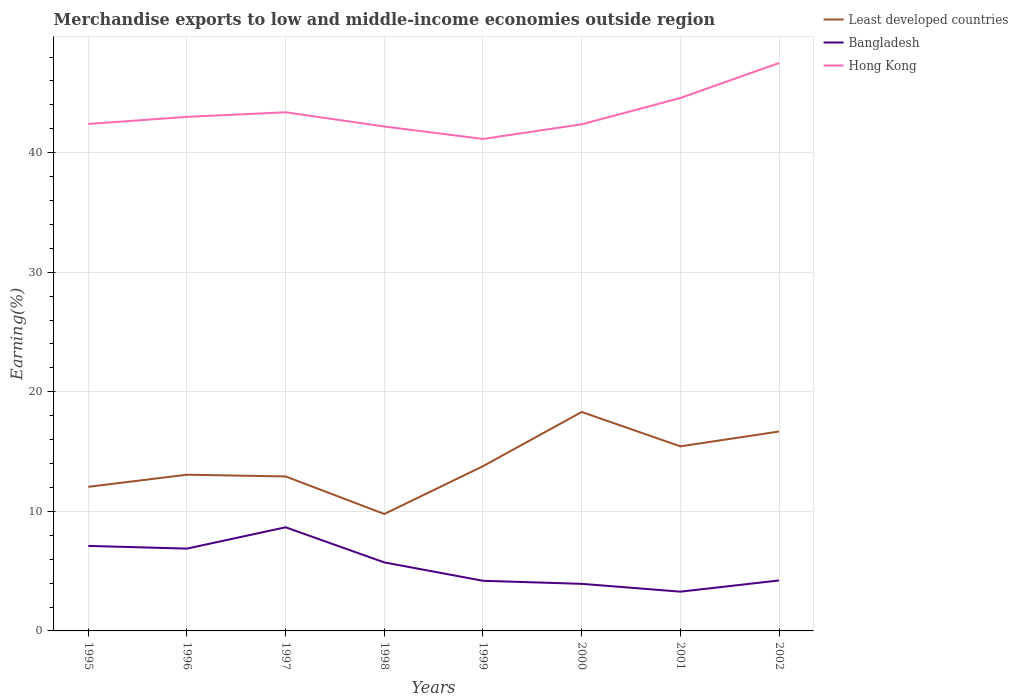Does the line corresponding to Least developed countries intersect with the line corresponding to Hong Kong?
Your response must be concise. No. Is the number of lines equal to the number of legend labels?
Provide a short and direct response. Yes. Across all years, what is the maximum percentage of amount earned from merchandise exports in Hong Kong?
Offer a very short reply. 41.15. What is the total percentage of amount earned from merchandise exports in Least developed countries in the graph?
Provide a succinct answer. -8.53. What is the difference between the highest and the second highest percentage of amount earned from merchandise exports in Least developed countries?
Your answer should be very brief. 8.53. What is the difference between the highest and the lowest percentage of amount earned from merchandise exports in Hong Kong?
Your response must be concise. 3. How many years are there in the graph?
Offer a very short reply. 8. Are the values on the major ticks of Y-axis written in scientific E-notation?
Ensure brevity in your answer.  No. Does the graph contain grids?
Provide a succinct answer. Yes. Where does the legend appear in the graph?
Keep it short and to the point. Top right. How are the legend labels stacked?
Provide a succinct answer. Vertical. What is the title of the graph?
Provide a succinct answer. Merchandise exports to low and middle-income economies outside region. Does "Bolivia" appear as one of the legend labels in the graph?
Provide a succinct answer. No. What is the label or title of the Y-axis?
Your answer should be compact. Earning(%). What is the Earning(%) in Least developed countries in 1995?
Offer a terse response. 12.05. What is the Earning(%) of Bangladesh in 1995?
Offer a terse response. 7.11. What is the Earning(%) in Hong Kong in 1995?
Give a very brief answer. 42.4. What is the Earning(%) in Least developed countries in 1996?
Provide a succinct answer. 13.07. What is the Earning(%) in Bangladesh in 1996?
Provide a short and direct response. 6.88. What is the Earning(%) of Hong Kong in 1996?
Your response must be concise. 43. What is the Earning(%) in Least developed countries in 1997?
Make the answer very short. 12.92. What is the Earning(%) in Bangladesh in 1997?
Offer a terse response. 8.67. What is the Earning(%) of Hong Kong in 1997?
Your answer should be very brief. 43.38. What is the Earning(%) of Least developed countries in 1998?
Offer a terse response. 9.78. What is the Earning(%) of Bangladesh in 1998?
Ensure brevity in your answer.  5.73. What is the Earning(%) in Hong Kong in 1998?
Offer a terse response. 42.19. What is the Earning(%) in Least developed countries in 1999?
Your answer should be compact. 13.78. What is the Earning(%) in Bangladesh in 1999?
Offer a very short reply. 4.19. What is the Earning(%) of Hong Kong in 1999?
Your response must be concise. 41.15. What is the Earning(%) of Least developed countries in 2000?
Give a very brief answer. 18.31. What is the Earning(%) in Bangladesh in 2000?
Ensure brevity in your answer.  3.94. What is the Earning(%) of Hong Kong in 2000?
Offer a very short reply. 42.37. What is the Earning(%) in Least developed countries in 2001?
Give a very brief answer. 15.44. What is the Earning(%) in Bangladesh in 2001?
Your answer should be very brief. 3.28. What is the Earning(%) of Hong Kong in 2001?
Keep it short and to the point. 44.58. What is the Earning(%) in Least developed countries in 2002?
Provide a succinct answer. 16.68. What is the Earning(%) of Bangladesh in 2002?
Offer a terse response. 4.22. What is the Earning(%) in Hong Kong in 2002?
Ensure brevity in your answer.  47.5. Across all years, what is the maximum Earning(%) of Least developed countries?
Your response must be concise. 18.31. Across all years, what is the maximum Earning(%) of Bangladesh?
Give a very brief answer. 8.67. Across all years, what is the maximum Earning(%) in Hong Kong?
Give a very brief answer. 47.5. Across all years, what is the minimum Earning(%) of Least developed countries?
Offer a very short reply. 9.78. Across all years, what is the minimum Earning(%) of Bangladesh?
Offer a very short reply. 3.28. Across all years, what is the minimum Earning(%) in Hong Kong?
Ensure brevity in your answer.  41.15. What is the total Earning(%) in Least developed countries in the graph?
Give a very brief answer. 112.03. What is the total Earning(%) in Bangladesh in the graph?
Make the answer very short. 44.03. What is the total Earning(%) in Hong Kong in the graph?
Offer a terse response. 346.57. What is the difference between the Earning(%) in Least developed countries in 1995 and that in 1996?
Your answer should be compact. -1.01. What is the difference between the Earning(%) of Bangladesh in 1995 and that in 1996?
Your answer should be very brief. 0.23. What is the difference between the Earning(%) of Hong Kong in 1995 and that in 1996?
Provide a short and direct response. -0.6. What is the difference between the Earning(%) of Least developed countries in 1995 and that in 1997?
Your answer should be very brief. -0.87. What is the difference between the Earning(%) of Bangladesh in 1995 and that in 1997?
Your response must be concise. -1.56. What is the difference between the Earning(%) in Hong Kong in 1995 and that in 1997?
Your response must be concise. -0.98. What is the difference between the Earning(%) of Least developed countries in 1995 and that in 1998?
Give a very brief answer. 2.27. What is the difference between the Earning(%) in Bangladesh in 1995 and that in 1998?
Your response must be concise. 1.38. What is the difference between the Earning(%) of Hong Kong in 1995 and that in 1998?
Offer a terse response. 0.21. What is the difference between the Earning(%) in Least developed countries in 1995 and that in 1999?
Keep it short and to the point. -1.73. What is the difference between the Earning(%) in Bangladesh in 1995 and that in 1999?
Make the answer very short. 2.92. What is the difference between the Earning(%) of Hong Kong in 1995 and that in 1999?
Offer a very short reply. 1.25. What is the difference between the Earning(%) of Least developed countries in 1995 and that in 2000?
Offer a very short reply. -6.26. What is the difference between the Earning(%) in Bangladesh in 1995 and that in 2000?
Offer a terse response. 3.17. What is the difference between the Earning(%) of Hong Kong in 1995 and that in 2000?
Your answer should be compact. 0.03. What is the difference between the Earning(%) of Least developed countries in 1995 and that in 2001?
Make the answer very short. -3.39. What is the difference between the Earning(%) in Bangladesh in 1995 and that in 2001?
Give a very brief answer. 3.83. What is the difference between the Earning(%) of Hong Kong in 1995 and that in 2001?
Provide a short and direct response. -2.17. What is the difference between the Earning(%) in Least developed countries in 1995 and that in 2002?
Offer a very short reply. -4.63. What is the difference between the Earning(%) in Bangladesh in 1995 and that in 2002?
Ensure brevity in your answer.  2.89. What is the difference between the Earning(%) in Hong Kong in 1995 and that in 2002?
Provide a short and direct response. -5.1. What is the difference between the Earning(%) of Least developed countries in 1996 and that in 1997?
Offer a very short reply. 0.14. What is the difference between the Earning(%) in Bangladesh in 1996 and that in 1997?
Your response must be concise. -1.78. What is the difference between the Earning(%) of Hong Kong in 1996 and that in 1997?
Keep it short and to the point. -0.38. What is the difference between the Earning(%) in Least developed countries in 1996 and that in 1998?
Offer a terse response. 3.29. What is the difference between the Earning(%) in Bangladesh in 1996 and that in 1998?
Offer a very short reply. 1.15. What is the difference between the Earning(%) of Hong Kong in 1996 and that in 1998?
Your answer should be compact. 0.81. What is the difference between the Earning(%) in Least developed countries in 1996 and that in 1999?
Offer a terse response. -0.71. What is the difference between the Earning(%) in Bangladesh in 1996 and that in 1999?
Your answer should be compact. 2.69. What is the difference between the Earning(%) of Hong Kong in 1996 and that in 1999?
Provide a short and direct response. 1.85. What is the difference between the Earning(%) of Least developed countries in 1996 and that in 2000?
Offer a very short reply. -5.25. What is the difference between the Earning(%) in Bangladesh in 1996 and that in 2000?
Keep it short and to the point. 2.95. What is the difference between the Earning(%) in Hong Kong in 1996 and that in 2000?
Your response must be concise. 0.62. What is the difference between the Earning(%) of Least developed countries in 1996 and that in 2001?
Your answer should be compact. -2.37. What is the difference between the Earning(%) of Bangladesh in 1996 and that in 2001?
Your response must be concise. 3.6. What is the difference between the Earning(%) in Hong Kong in 1996 and that in 2001?
Your response must be concise. -1.58. What is the difference between the Earning(%) in Least developed countries in 1996 and that in 2002?
Your answer should be compact. -3.61. What is the difference between the Earning(%) in Bangladesh in 1996 and that in 2002?
Offer a terse response. 2.66. What is the difference between the Earning(%) of Hong Kong in 1996 and that in 2002?
Provide a short and direct response. -4.5. What is the difference between the Earning(%) of Least developed countries in 1997 and that in 1998?
Your answer should be very brief. 3.14. What is the difference between the Earning(%) of Bangladesh in 1997 and that in 1998?
Your response must be concise. 2.94. What is the difference between the Earning(%) of Hong Kong in 1997 and that in 1998?
Offer a very short reply. 1.19. What is the difference between the Earning(%) in Least developed countries in 1997 and that in 1999?
Your response must be concise. -0.86. What is the difference between the Earning(%) of Bangladesh in 1997 and that in 1999?
Offer a terse response. 4.47. What is the difference between the Earning(%) of Hong Kong in 1997 and that in 1999?
Your answer should be very brief. 2.23. What is the difference between the Earning(%) in Least developed countries in 1997 and that in 2000?
Your answer should be compact. -5.39. What is the difference between the Earning(%) in Bangladesh in 1997 and that in 2000?
Give a very brief answer. 4.73. What is the difference between the Earning(%) of Least developed countries in 1997 and that in 2001?
Provide a short and direct response. -2.52. What is the difference between the Earning(%) of Bangladesh in 1997 and that in 2001?
Your answer should be very brief. 5.38. What is the difference between the Earning(%) of Hong Kong in 1997 and that in 2001?
Offer a terse response. -1.19. What is the difference between the Earning(%) in Least developed countries in 1997 and that in 2002?
Give a very brief answer. -3.76. What is the difference between the Earning(%) in Bangladesh in 1997 and that in 2002?
Provide a short and direct response. 4.45. What is the difference between the Earning(%) in Hong Kong in 1997 and that in 2002?
Your response must be concise. -4.12. What is the difference between the Earning(%) in Least developed countries in 1998 and that in 1999?
Your answer should be very brief. -4. What is the difference between the Earning(%) in Bangladesh in 1998 and that in 1999?
Ensure brevity in your answer.  1.54. What is the difference between the Earning(%) of Hong Kong in 1998 and that in 1999?
Ensure brevity in your answer.  1.04. What is the difference between the Earning(%) of Least developed countries in 1998 and that in 2000?
Your response must be concise. -8.53. What is the difference between the Earning(%) of Bangladesh in 1998 and that in 2000?
Your response must be concise. 1.79. What is the difference between the Earning(%) of Hong Kong in 1998 and that in 2000?
Provide a short and direct response. -0.18. What is the difference between the Earning(%) in Least developed countries in 1998 and that in 2001?
Make the answer very short. -5.66. What is the difference between the Earning(%) in Bangladesh in 1998 and that in 2001?
Provide a succinct answer. 2.45. What is the difference between the Earning(%) of Hong Kong in 1998 and that in 2001?
Provide a short and direct response. -2.39. What is the difference between the Earning(%) of Least developed countries in 1998 and that in 2002?
Offer a terse response. -6.9. What is the difference between the Earning(%) of Bangladesh in 1998 and that in 2002?
Ensure brevity in your answer.  1.51. What is the difference between the Earning(%) of Hong Kong in 1998 and that in 2002?
Your response must be concise. -5.31. What is the difference between the Earning(%) in Least developed countries in 1999 and that in 2000?
Make the answer very short. -4.53. What is the difference between the Earning(%) in Bangladesh in 1999 and that in 2000?
Make the answer very short. 0.26. What is the difference between the Earning(%) in Hong Kong in 1999 and that in 2000?
Make the answer very short. -1.22. What is the difference between the Earning(%) in Least developed countries in 1999 and that in 2001?
Your answer should be compact. -1.66. What is the difference between the Earning(%) in Bangladesh in 1999 and that in 2001?
Your answer should be compact. 0.91. What is the difference between the Earning(%) of Hong Kong in 1999 and that in 2001?
Provide a succinct answer. -3.43. What is the difference between the Earning(%) in Least developed countries in 1999 and that in 2002?
Offer a terse response. -2.9. What is the difference between the Earning(%) of Bangladesh in 1999 and that in 2002?
Give a very brief answer. -0.03. What is the difference between the Earning(%) in Hong Kong in 1999 and that in 2002?
Provide a succinct answer. -6.35. What is the difference between the Earning(%) of Least developed countries in 2000 and that in 2001?
Offer a very short reply. 2.87. What is the difference between the Earning(%) of Bangladesh in 2000 and that in 2001?
Make the answer very short. 0.65. What is the difference between the Earning(%) of Hong Kong in 2000 and that in 2001?
Give a very brief answer. -2.2. What is the difference between the Earning(%) in Least developed countries in 2000 and that in 2002?
Your answer should be compact. 1.63. What is the difference between the Earning(%) in Bangladesh in 2000 and that in 2002?
Offer a very short reply. -0.28. What is the difference between the Earning(%) of Hong Kong in 2000 and that in 2002?
Keep it short and to the point. -5.13. What is the difference between the Earning(%) of Least developed countries in 2001 and that in 2002?
Keep it short and to the point. -1.24. What is the difference between the Earning(%) of Bangladesh in 2001 and that in 2002?
Your response must be concise. -0.94. What is the difference between the Earning(%) of Hong Kong in 2001 and that in 2002?
Offer a terse response. -2.93. What is the difference between the Earning(%) of Least developed countries in 1995 and the Earning(%) of Bangladesh in 1996?
Your answer should be compact. 5.17. What is the difference between the Earning(%) in Least developed countries in 1995 and the Earning(%) in Hong Kong in 1996?
Your answer should be compact. -30.94. What is the difference between the Earning(%) of Bangladesh in 1995 and the Earning(%) of Hong Kong in 1996?
Give a very brief answer. -35.89. What is the difference between the Earning(%) in Least developed countries in 1995 and the Earning(%) in Bangladesh in 1997?
Ensure brevity in your answer.  3.38. What is the difference between the Earning(%) in Least developed countries in 1995 and the Earning(%) in Hong Kong in 1997?
Keep it short and to the point. -31.33. What is the difference between the Earning(%) in Bangladesh in 1995 and the Earning(%) in Hong Kong in 1997?
Offer a terse response. -36.27. What is the difference between the Earning(%) in Least developed countries in 1995 and the Earning(%) in Bangladesh in 1998?
Your answer should be very brief. 6.32. What is the difference between the Earning(%) in Least developed countries in 1995 and the Earning(%) in Hong Kong in 1998?
Give a very brief answer. -30.14. What is the difference between the Earning(%) of Bangladesh in 1995 and the Earning(%) of Hong Kong in 1998?
Provide a short and direct response. -35.08. What is the difference between the Earning(%) in Least developed countries in 1995 and the Earning(%) in Bangladesh in 1999?
Keep it short and to the point. 7.86. What is the difference between the Earning(%) of Least developed countries in 1995 and the Earning(%) of Hong Kong in 1999?
Offer a very short reply. -29.1. What is the difference between the Earning(%) in Bangladesh in 1995 and the Earning(%) in Hong Kong in 1999?
Your answer should be very brief. -34.04. What is the difference between the Earning(%) in Least developed countries in 1995 and the Earning(%) in Bangladesh in 2000?
Provide a succinct answer. 8.11. What is the difference between the Earning(%) in Least developed countries in 1995 and the Earning(%) in Hong Kong in 2000?
Your answer should be very brief. -30.32. What is the difference between the Earning(%) of Bangladesh in 1995 and the Earning(%) of Hong Kong in 2000?
Make the answer very short. -35.26. What is the difference between the Earning(%) in Least developed countries in 1995 and the Earning(%) in Bangladesh in 2001?
Give a very brief answer. 8.77. What is the difference between the Earning(%) of Least developed countries in 1995 and the Earning(%) of Hong Kong in 2001?
Give a very brief answer. -32.52. What is the difference between the Earning(%) of Bangladesh in 1995 and the Earning(%) of Hong Kong in 2001?
Provide a succinct answer. -37.46. What is the difference between the Earning(%) of Least developed countries in 1995 and the Earning(%) of Bangladesh in 2002?
Give a very brief answer. 7.83. What is the difference between the Earning(%) of Least developed countries in 1995 and the Earning(%) of Hong Kong in 2002?
Your answer should be very brief. -35.45. What is the difference between the Earning(%) of Bangladesh in 1995 and the Earning(%) of Hong Kong in 2002?
Offer a terse response. -40.39. What is the difference between the Earning(%) of Least developed countries in 1996 and the Earning(%) of Bangladesh in 1997?
Make the answer very short. 4.4. What is the difference between the Earning(%) of Least developed countries in 1996 and the Earning(%) of Hong Kong in 1997?
Keep it short and to the point. -30.32. What is the difference between the Earning(%) in Bangladesh in 1996 and the Earning(%) in Hong Kong in 1997?
Your response must be concise. -36.5. What is the difference between the Earning(%) in Least developed countries in 1996 and the Earning(%) in Bangladesh in 1998?
Offer a terse response. 7.33. What is the difference between the Earning(%) in Least developed countries in 1996 and the Earning(%) in Hong Kong in 1998?
Provide a short and direct response. -29.12. What is the difference between the Earning(%) of Bangladesh in 1996 and the Earning(%) of Hong Kong in 1998?
Keep it short and to the point. -35.3. What is the difference between the Earning(%) in Least developed countries in 1996 and the Earning(%) in Bangladesh in 1999?
Keep it short and to the point. 8.87. What is the difference between the Earning(%) in Least developed countries in 1996 and the Earning(%) in Hong Kong in 1999?
Provide a succinct answer. -28.08. What is the difference between the Earning(%) of Bangladesh in 1996 and the Earning(%) of Hong Kong in 1999?
Ensure brevity in your answer.  -34.27. What is the difference between the Earning(%) of Least developed countries in 1996 and the Earning(%) of Bangladesh in 2000?
Offer a terse response. 9.13. What is the difference between the Earning(%) of Least developed countries in 1996 and the Earning(%) of Hong Kong in 2000?
Provide a succinct answer. -29.31. What is the difference between the Earning(%) in Bangladesh in 1996 and the Earning(%) in Hong Kong in 2000?
Your answer should be compact. -35.49. What is the difference between the Earning(%) of Least developed countries in 1996 and the Earning(%) of Bangladesh in 2001?
Provide a short and direct response. 9.78. What is the difference between the Earning(%) of Least developed countries in 1996 and the Earning(%) of Hong Kong in 2001?
Provide a short and direct response. -31.51. What is the difference between the Earning(%) in Bangladesh in 1996 and the Earning(%) in Hong Kong in 2001?
Provide a short and direct response. -37.69. What is the difference between the Earning(%) of Least developed countries in 1996 and the Earning(%) of Bangladesh in 2002?
Your answer should be very brief. 8.85. What is the difference between the Earning(%) in Least developed countries in 1996 and the Earning(%) in Hong Kong in 2002?
Keep it short and to the point. -34.44. What is the difference between the Earning(%) of Bangladesh in 1996 and the Earning(%) of Hong Kong in 2002?
Your answer should be very brief. -40.62. What is the difference between the Earning(%) in Least developed countries in 1997 and the Earning(%) in Bangladesh in 1998?
Your response must be concise. 7.19. What is the difference between the Earning(%) in Least developed countries in 1997 and the Earning(%) in Hong Kong in 1998?
Your answer should be very brief. -29.27. What is the difference between the Earning(%) of Bangladesh in 1997 and the Earning(%) of Hong Kong in 1998?
Ensure brevity in your answer.  -33.52. What is the difference between the Earning(%) in Least developed countries in 1997 and the Earning(%) in Bangladesh in 1999?
Give a very brief answer. 8.73. What is the difference between the Earning(%) in Least developed countries in 1997 and the Earning(%) in Hong Kong in 1999?
Provide a succinct answer. -28.23. What is the difference between the Earning(%) of Bangladesh in 1997 and the Earning(%) of Hong Kong in 1999?
Give a very brief answer. -32.48. What is the difference between the Earning(%) of Least developed countries in 1997 and the Earning(%) of Bangladesh in 2000?
Offer a terse response. 8.98. What is the difference between the Earning(%) in Least developed countries in 1997 and the Earning(%) in Hong Kong in 2000?
Ensure brevity in your answer.  -29.45. What is the difference between the Earning(%) in Bangladesh in 1997 and the Earning(%) in Hong Kong in 2000?
Provide a succinct answer. -33.71. What is the difference between the Earning(%) of Least developed countries in 1997 and the Earning(%) of Bangladesh in 2001?
Provide a succinct answer. 9.64. What is the difference between the Earning(%) of Least developed countries in 1997 and the Earning(%) of Hong Kong in 2001?
Provide a short and direct response. -31.65. What is the difference between the Earning(%) in Bangladesh in 1997 and the Earning(%) in Hong Kong in 2001?
Make the answer very short. -35.91. What is the difference between the Earning(%) in Least developed countries in 1997 and the Earning(%) in Bangladesh in 2002?
Your answer should be very brief. 8.7. What is the difference between the Earning(%) in Least developed countries in 1997 and the Earning(%) in Hong Kong in 2002?
Make the answer very short. -34.58. What is the difference between the Earning(%) in Bangladesh in 1997 and the Earning(%) in Hong Kong in 2002?
Offer a terse response. -38.83. What is the difference between the Earning(%) in Least developed countries in 1998 and the Earning(%) in Bangladesh in 1999?
Your response must be concise. 5.59. What is the difference between the Earning(%) in Least developed countries in 1998 and the Earning(%) in Hong Kong in 1999?
Offer a terse response. -31.37. What is the difference between the Earning(%) in Bangladesh in 1998 and the Earning(%) in Hong Kong in 1999?
Provide a succinct answer. -35.42. What is the difference between the Earning(%) of Least developed countries in 1998 and the Earning(%) of Bangladesh in 2000?
Your answer should be very brief. 5.84. What is the difference between the Earning(%) in Least developed countries in 1998 and the Earning(%) in Hong Kong in 2000?
Provide a short and direct response. -32.59. What is the difference between the Earning(%) in Bangladesh in 1998 and the Earning(%) in Hong Kong in 2000?
Offer a terse response. -36.64. What is the difference between the Earning(%) in Least developed countries in 1998 and the Earning(%) in Bangladesh in 2001?
Offer a very short reply. 6.5. What is the difference between the Earning(%) of Least developed countries in 1998 and the Earning(%) of Hong Kong in 2001?
Your answer should be very brief. -34.8. What is the difference between the Earning(%) of Bangladesh in 1998 and the Earning(%) of Hong Kong in 2001?
Ensure brevity in your answer.  -38.84. What is the difference between the Earning(%) of Least developed countries in 1998 and the Earning(%) of Bangladesh in 2002?
Offer a very short reply. 5.56. What is the difference between the Earning(%) in Least developed countries in 1998 and the Earning(%) in Hong Kong in 2002?
Give a very brief answer. -37.72. What is the difference between the Earning(%) of Bangladesh in 1998 and the Earning(%) of Hong Kong in 2002?
Offer a terse response. -41.77. What is the difference between the Earning(%) in Least developed countries in 1999 and the Earning(%) in Bangladesh in 2000?
Make the answer very short. 9.84. What is the difference between the Earning(%) of Least developed countries in 1999 and the Earning(%) of Hong Kong in 2000?
Offer a very short reply. -28.59. What is the difference between the Earning(%) in Bangladesh in 1999 and the Earning(%) in Hong Kong in 2000?
Keep it short and to the point. -38.18. What is the difference between the Earning(%) of Least developed countries in 1999 and the Earning(%) of Bangladesh in 2001?
Make the answer very short. 10.5. What is the difference between the Earning(%) of Least developed countries in 1999 and the Earning(%) of Hong Kong in 2001?
Make the answer very short. -30.8. What is the difference between the Earning(%) in Bangladesh in 1999 and the Earning(%) in Hong Kong in 2001?
Give a very brief answer. -40.38. What is the difference between the Earning(%) in Least developed countries in 1999 and the Earning(%) in Bangladesh in 2002?
Offer a terse response. 9.56. What is the difference between the Earning(%) in Least developed countries in 1999 and the Earning(%) in Hong Kong in 2002?
Your response must be concise. -33.72. What is the difference between the Earning(%) in Bangladesh in 1999 and the Earning(%) in Hong Kong in 2002?
Offer a terse response. -43.31. What is the difference between the Earning(%) of Least developed countries in 2000 and the Earning(%) of Bangladesh in 2001?
Ensure brevity in your answer.  15.03. What is the difference between the Earning(%) in Least developed countries in 2000 and the Earning(%) in Hong Kong in 2001?
Your answer should be compact. -26.26. What is the difference between the Earning(%) of Bangladesh in 2000 and the Earning(%) of Hong Kong in 2001?
Ensure brevity in your answer.  -40.64. What is the difference between the Earning(%) of Least developed countries in 2000 and the Earning(%) of Bangladesh in 2002?
Make the answer very short. 14.09. What is the difference between the Earning(%) of Least developed countries in 2000 and the Earning(%) of Hong Kong in 2002?
Your answer should be compact. -29.19. What is the difference between the Earning(%) of Bangladesh in 2000 and the Earning(%) of Hong Kong in 2002?
Offer a very short reply. -43.56. What is the difference between the Earning(%) of Least developed countries in 2001 and the Earning(%) of Bangladesh in 2002?
Your answer should be very brief. 11.22. What is the difference between the Earning(%) in Least developed countries in 2001 and the Earning(%) in Hong Kong in 2002?
Your answer should be very brief. -32.06. What is the difference between the Earning(%) in Bangladesh in 2001 and the Earning(%) in Hong Kong in 2002?
Offer a very short reply. -44.22. What is the average Earning(%) in Least developed countries per year?
Give a very brief answer. 14. What is the average Earning(%) in Bangladesh per year?
Keep it short and to the point. 5.5. What is the average Earning(%) of Hong Kong per year?
Offer a very short reply. 43.32. In the year 1995, what is the difference between the Earning(%) in Least developed countries and Earning(%) in Bangladesh?
Make the answer very short. 4.94. In the year 1995, what is the difference between the Earning(%) of Least developed countries and Earning(%) of Hong Kong?
Your response must be concise. -30.35. In the year 1995, what is the difference between the Earning(%) of Bangladesh and Earning(%) of Hong Kong?
Your answer should be very brief. -35.29. In the year 1996, what is the difference between the Earning(%) of Least developed countries and Earning(%) of Bangladesh?
Your answer should be compact. 6.18. In the year 1996, what is the difference between the Earning(%) of Least developed countries and Earning(%) of Hong Kong?
Your answer should be very brief. -29.93. In the year 1996, what is the difference between the Earning(%) of Bangladesh and Earning(%) of Hong Kong?
Give a very brief answer. -36.11. In the year 1997, what is the difference between the Earning(%) of Least developed countries and Earning(%) of Bangladesh?
Give a very brief answer. 4.25. In the year 1997, what is the difference between the Earning(%) in Least developed countries and Earning(%) in Hong Kong?
Provide a short and direct response. -30.46. In the year 1997, what is the difference between the Earning(%) in Bangladesh and Earning(%) in Hong Kong?
Keep it short and to the point. -34.71. In the year 1998, what is the difference between the Earning(%) in Least developed countries and Earning(%) in Bangladesh?
Offer a very short reply. 4.05. In the year 1998, what is the difference between the Earning(%) in Least developed countries and Earning(%) in Hong Kong?
Your response must be concise. -32.41. In the year 1998, what is the difference between the Earning(%) in Bangladesh and Earning(%) in Hong Kong?
Give a very brief answer. -36.46. In the year 1999, what is the difference between the Earning(%) in Least developed countries and Earning(%) in Bangladesh?
Give a very brief answer. 9.59. In the year 1999, what is the difference between the Earning(%) of Least developed countries and Earning(%) of Hong Kong?
Offer a very short reply. -27.37. In the year 1999, what is the difference between the Earning(%) in Bangladesh and Earning(%) in Hong Kong?
Make the answer very short. -36.96. In the year 2000, what is the difference between the Earning(%) of Least developed countries and Earning(%) of Bangladesh?
Offer a very short reply. 14.37. In the year 2000, what is the difference between the Earning(%) of Least developed countries and Earning(%) of Hong Kong?
Offer a terse response. -24.06. In the year 2000, what is the difference between the Earning(%) in Bangladesh and Earning(%) in Hong Kong?
Provide a short and direct response. -38.44. In the year 2001, what is the difference between the Earning(%) of Least developed countries and Earning(%) of Bangladesh?
Ensure brevity in your answer.  12.16. In the year 2001, what is the difference between the Earning(%) of Least developed countries and Earning(%) of Hong Kong?
Make the answer very short. -29.14. In the year 2001, what is the difference between the Earning(%) in Bangladesh and Earning(%) in Hong Kong?
Keep it short and to the point. -41.29. In the year 2002, what is the difference between the Earning(%) of Least developed countries and Earning(%) of Bangladesh?
Make the answer very short. 12.46. In the year 2002, what is the difference between the Earning(%) in Least developed countries and Earning(%) in Hong Kong?
Ensure brevity in your answer.  -30.82. In the year 2002, what is the difference between the Earning(%) of Bangladesh and Earning(%) of Hong Kong?
Your answer should be very brief. -43.28. What is the ratio of the Earning(%) in Least developed countries in 1995 to that in 1996?
Give a very brief answer. 0.92. What is the ratio of the Earning(%) of Bangladesh in 1995 to that in 1996?
Ensure brevity in your answer.  1.03. What is the ratio of the Earning(%) in Hong Kong in 1995 to that in 1996?
Make the answer very short. 0.99. What is the ratio of the Earning(%) in Least developed countries in 1995 to that in 1997?
Offer a very short reply. 0.93. What is the ratio of the Earning(%) of Bangladesh in 1995 to that in 1997?
Make the answer very short. 0.82. What is the ratio of the Earning(%) of Hong Kong in 1995 to that in 1997?
Your answer should be compact. 0.98. What is the ratio of the Earning(%) of Least developed countries in 1995 to that in 1998?
Provide a short and direct response. 1.23. What is the ratio of the Earning(%) of Bangladesh in 1995 to that in 1998?
Your answer should be very brief. 1.24. What is the ratio of the Earning(%) of Hong Kong in 1995 to that in 1998?
Provide a short and direct response. 1. What is the ratio of the Earning(%) of Least developed countries in 1995 to that in 1999?
Offer a very short reply. 0.87. What is the ratio of the Earning(%) of Bangladesh in 1995 to that in 1999?
Provide a succinct answer. 1.7. What is the ratio of the Earning(%) in Hong Kong in 1995 to that in 1999?
Provide a succinct answer. 1.03. What is the ratio of the Earning(%) of Least developed countries in 1995 to that in 2000?
Your response must be concise. 0.66. What is the ratio of the Earning(%) of Bangladesh in 1995 to that in 2000?
Offer a terse response. 1.81. What is the ratio of the Earning(%) in Least developed countries in 1995 to that in 2001?
Keep it short and to the point. 0.78. What is the ratio of the Earning(%) in Bangladesh in 1995 to that in 2001?
Your answer should be very brief. 2.17. What is the ratio of the Earning(%) in Hong Kong in 1995 to that in 2001?
Keep it short and to the point. 0.95. What is the ratio of the Earning(%) in Least developed countries in 1995 to that in 2002?
Offer a very short reply. 0.72. What is the ratio of the Earning(%) in Bangladesh in 1995 to that in 2002?
Offer a terse response. 1.69. What is the ratio of the Earning(%) in Hong Kong in 1995 to that in 2002?
Your answer should be very brief. 0.89. What is the ratio of the Earning(%) in Least developed countries in 1996 to that in 1997?
Make the answer very short. 1.01. What is the ratio of the Earning(%) in Bangladesh in 1996 to that in 1997?
Your answer should be very brief. 0.79. What is the ratio of the Earning(%) of Least developed countries in 1996 to that in 1998?
Your answer should be compact. 1.34. What is the ratio of the Earning(%) in Bangladesh in 1996 to that in 1998?
Keep it short and to the point. 1.2. What is the ratio of the Earning(%) in Hong Kong in 1996 to that in 1998?
Make the answer very short. 1.02. What is the ratio of the Earning(%) in Least developed countries in 1996 to that in 1999?
Provide a short and direct response. 0.95. What is the ratio of the Earning(%) of Bangladesh in 1996 to that in 1999?
Keep it short and to the point. 1.64. What is the ratio of the Earning(%) in Hong Kong in 1996 to that in 1999?
Offer a very short reply. 1.04. What is the ratio of the Earning(%) in Least developed countries in 1996 to that in 2000?
Your response must be concise. 0.71. What is the ratio of the Earning(%) of Bangladesh in 1996 to that in 2000?
Keep it short and to the point. 1.75. What is the ratio of the Earning(%) of Hong Kong in 1996 to that in 2000?
Provide a short and direct response. 1.01. What is the ratio of the Earning(%) in Least developed countries in 1996 to that in 2001?
Make the answer very short. 0.85. What is the ratio of the Earning(%) of Bangladesh in 1996 to that in 2001?
Your answer should be compact. 2.1. What is the ratio of the Earning(%) in Hong Kong in 1996 to that in 2001?
Provide a short and direct response. 0.96. What is the ratio of the Earning(%) of Least developed countries in 1996 to that in 2002?
Keep it short and to the point. 0.78. What is the ratio of the Earning(%) in Bangladesh in 1996 to that in 2002?
Offer a terse response. 1.63. What is the ratio of the Earning(%) of Hong Kong in 1996 to that in 2002?
Ensure brevity in your answer.  0.91. What is the ratio of the Earning(%) of Least developed countries in 1997 to that in 1998?
Give a very brief answer. 1.32. What is the ratio of the Earning(%) in Bangladesh in 1997 to that in 1998?
Provide a succinct answer. 1.51. What is the ratio of the Earning(%) of Hong Kong in 1997 to that in 1998?
Make the answer very short. 1.03. What is the ratio of the Earning(%) of Least developed countries in 1997 to that in 1999?
Keep it short and to the point. 0.94. What is the ratio of the Earning(%) in Bangladesh in 1997 to that in 1999?
Your answer should be compact. 2.07. What is the ratio of the Earning(%) in Hong Kong in 1997 to that in 1999?
Offer a terse response. 1.05. What is the ratio of the Earning(%) in Least developed countries in 1997 to that in 2000?
Offer a terse response. 0.71. What is the ratio of the Earning(%) in Bangladesh in 1997 to that in 2000?
Keep it short and to the point. 2.2. What is the ratio of the Earning(%) in Hong Kong in 1997 to that in 2000?
Provide a succinct answer. 1.02. What is the ratio of the Earning(%) of Least developed countries in 1997 to that in 2001?
Offer a terse response. 0.84. What is the ratio of the Earning(%) of Bangladesh in 1997 to that in 2001?
Make the answer very short. 2.64. What is the ratio of the Earning(%) of Hong Kong in 1997 to that in 2001?
Your response must be concise. 0.97. What is the ratio of the Earning(%) in Least developed countries in 1997 to that in 2002?
Provide a succinct answer. 0.77. What is the ratio of the Earning(%) in Bangladesh in 1997 to that in 2002?
Your response must be concise. 2.05. What is the ratio of the Earning(%) of Hong Kong in 1997 to that in 2002?
Provide a short and direct response. 0.91. What is the ratio of the Earning(%) in Least developed countries in 1998 to that in 1999?
Your answer should be compact. 0.71. What is the ratio of the Earning(%) of Bangladesh in 1998 to that in 1999?
Make the answer very short. 1.37. What is the ratio of the Earning(%) of Hong Kong in 1998 to that in 1999?
Provide a succinct answer. 1.03. What is the ratio of the Earning(%) in Least developed countries in 1998 to that in 2000?
Make the answer very short. 0.53. What is the ratio of the Earning(%) of Bangladesh in 1998 to that in 2000?
Give a very brief answer. 1.46. What is the ratio of the Earning(%) of Least developed countries in 1998 to that in 2001?
Your answer should be very brief. 0.63. What is the ratio of the Earning(%) in Bangladesh in 1998 to that in 2001?
Your answer should be compact. 1.75. What is the ratio of the Earning(%) in Hong Kong in 1998 to that in 2001?
Your answer should be very brief. 0.95. What is the ratio of the Earning(%) of Least developed countries in 1998 to that in 2002?
Give a very brief answer. 0.59. What is the ratio of the Earning(%) in Bangladesh in 1998 to that in 2002?
Your answer should be compact. 1.36. What is the ratio of the Earning(%) in Hong Kong in 1998 to that in 2002?
Keep it short and to the point. 0.89. What is the ratio of the Earning(%) in Least developed countries in 1999 to that in 2000?
Your response must be concise. 0.75. What is the ratio of the Earning(%) of Bangladesh in 1999 to that in 2000?
Your response must be concise. 1.07. What is the ratio of the Earning(%) in Hong Kong in 1999 to that in 2000?
Give a very brief answer. 0.97. What is the ratio of the Earning(%) of Least developed countries in 1999 to that in 2001?
Your answer should be compact. 0.89. What is the ratio of the Earning(%) in Bangladesh in 1999 to that in 2001?
Your answer should be compact. 1.28. What is the ratio of the Earning(%) in Hong Kong in 1999 to that in 2001?
Offer a terse response. 0.92. What is the ratio of the Earning(%) in Least developed countries in 1999 to that in 2002?
Keep it short and to the point. 0.83. What is the ratio of the Earning(%) in Hong Kong in 1999 to that in 2002?
Your answer should be very brief. 0.87. What is the ratio of the Earning(%) of Least developed countries in 2000 to that in 2001?
Give a very brief answer. 1.19. What is the ratio of the Earning(%) of Bangladesh in 2000 to that in 2001?
Offer a terse response. 1.2. What is the ratio of the Earning(%) in Hong Kong in 2000 to that in 2001?
Provide a succinct answer. 0.95. What is the ratio of the Earning(%) in Least developed countries in 2000 to that in 2002?
Keep it short and to the point. 1.1. What is the ratio of the Earning(%) of Bangladesh in 2000 to that in 2002?
Your response must be concise. 0.93. What is the ratio of the Earning(%) in Hong Kong in 2000 to that in 2002?
Your answer should be very brief. 0.89. What is the ratio of the Earning(%) in Least developed countries in 2001 to that in 2002?
Your answer should be very brief. 0.93. What is the ratio of the Earning(%) of Bangladesh in 2001 to that in 2002?
Offer a very short reply. 0.78. What is the ratio of the Earning(%) in Hong Kong in 2001 to that in 2002?
Your response must be concise. 0.94. What is the difference between the highest and the second highest Earning(%) of Least developed countries?
Make the answer very short. 1.63. What is the difference between the highest and the second highest Earning(%) in Bangladesh?
Your answer should be very brief. 1.56. What is the difference between the highest and the second highest Earning(%) in Hong Kong?
Provide a short and direct response. 2.93. What is the difference between the highest and the lowest Earning(%) in Least developed countries?
Offer a terse response. 8.53. What is the difference between the highest and the lowest Earning(%) in Bangladesh?
Provide a succinct answer. 5.38. What is the difference between the highest and the lowest Earning(%) of Hong Kong?
Give a very brief answer. 6.35. 